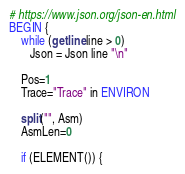Convert code to text. <code><loc_0><loc_0><loc_500><loc_500><_Awk_># https://www.json.org/json-en.html
BEGIN {
    while (getline line > 0)
       Json = Json line "\n"

    Pos=1
    Trace="Trace" in ENVIRON

    split("", Asm)
    AsmLen=0

    if (ELEMENT()) {</code> 